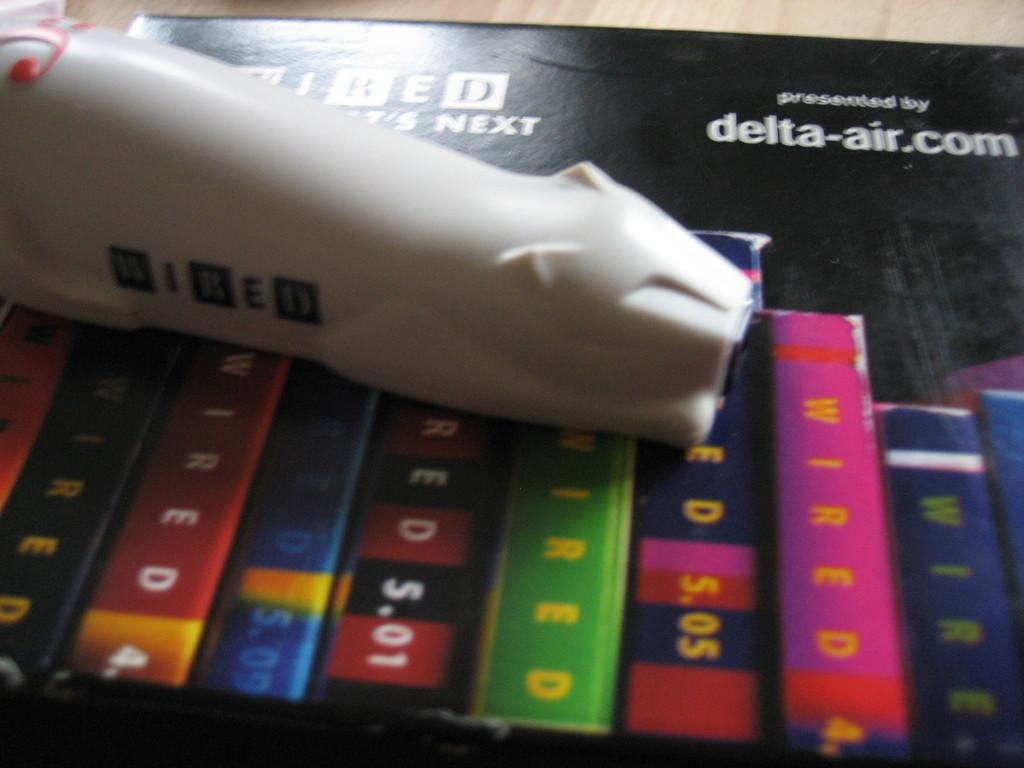<image>
Present a compact description of the photo's key features. A black picture that has been presented by delta-air.com. 